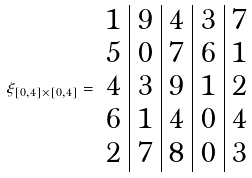<formula> <loc_0><loc_0><loc_500><loc_500>\xi _ { [ 0 , 4 ] \times [ 0 , 4 ] } = \begin{array} { c | c | c | c | c } 1 & 9 & 4 & 3 & 7 \\ 5 & 0 & 7 & 6 & 1 \\ 4 & 3 & 9 & 1 & 2 \\ 6 & 1 & 4 & 0 & 4 \\ 2 & 7 & 8 & 0 & 3 \end{array}</formula> 